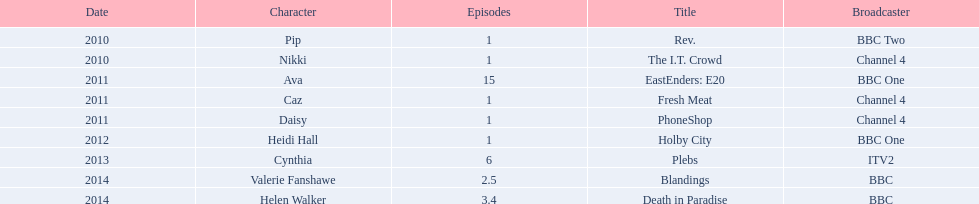Which characters were featured in more then one episode? Ava, Cynthia, Valerie Fanshawe, Helen Walker. Which of these were not in 2014? Ava, Cynthia. Which one of those was not on a bbc broadcaster? Cynthia. 